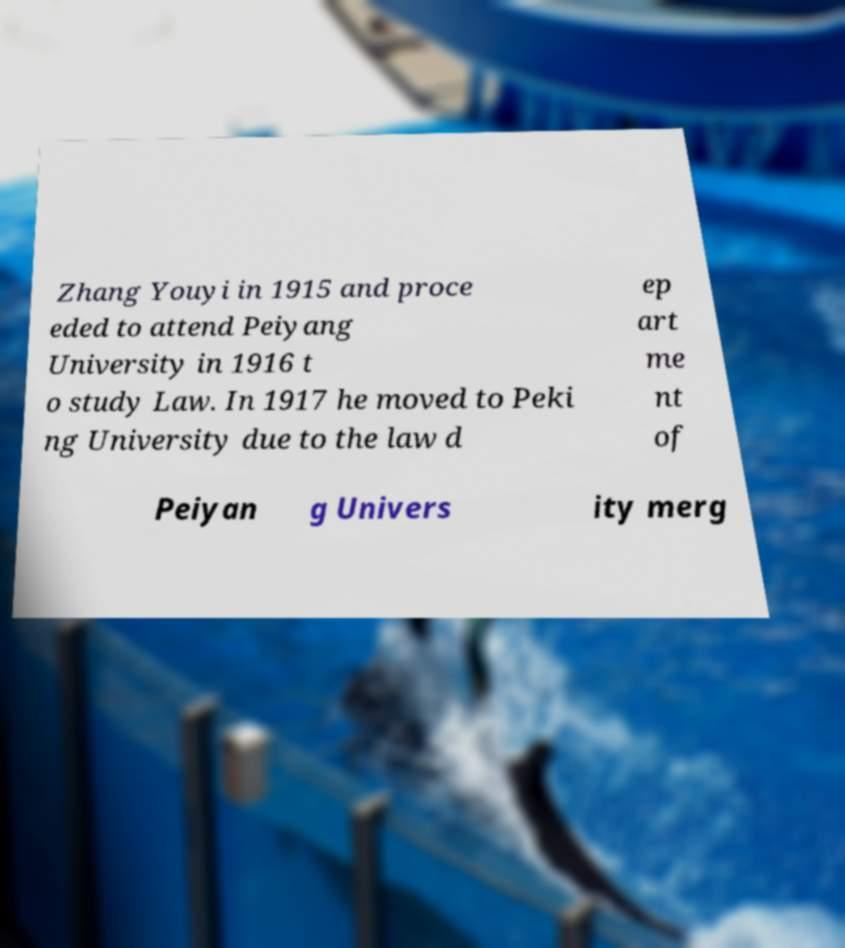Please read and relay the text visible in this image. What does it say? Zhang Youyi in 1915 and proce eded to attend Peiyang University in 1916 t o study Law. In 1917 he moved to Peki ng University due to the law d ep art me nt of Peiyan g Univers ity merg 